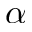Convert formula to latex. <formula><loc_0><loc_0><loc_500><loc_500>\alpha</formula> 